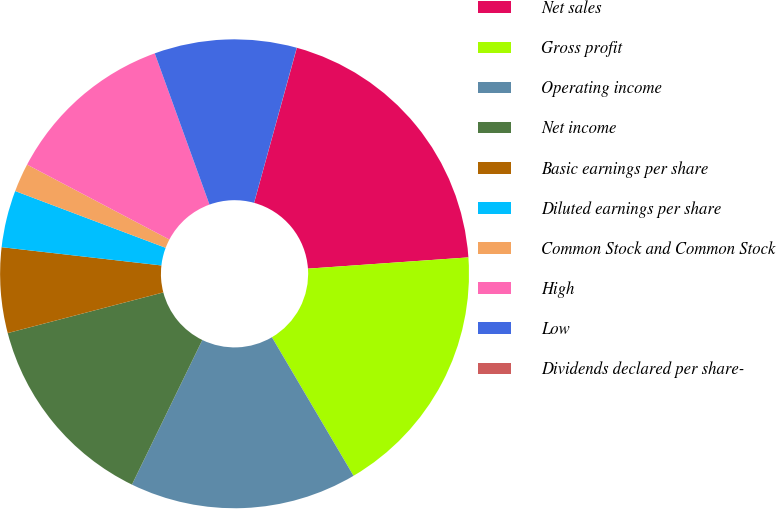<chart> <loc_0><loc_0><loc_500><loc_500><pie_chart><fcel>Net sales<fcel>Gross profit<fcel>Operating income<fcel>Net income<fcel>Basic earnings per share<fcel>Diluted earnings per share<fcel>Common Stock and Common Stock<fcel>High<fcel>Low<fcel>Dividends declared per share-<nl><fcel>19.6%<fcel>17.64%<fcel>15.68%<fcel>13.72%<fcel>5.88%<fcel>3.93%<fcel>1.97%<fcel>11.76%<fcel>9.8%<fcel>0.01%<nl></chart> 